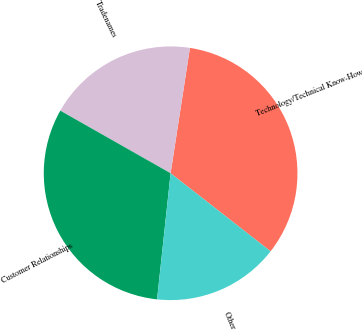Convert chart to OTSL. <chart><loc_0><loc_0><loc_500><loc_500><pie_chart><fcel>Technology/Technical Know-How<fcel>Tradenames<fcel>Customer Relationships<fcel>Other<nl><fcel>33.12%<fcel>19.22%<fcel>31.51%<fcel>16.15%<nl></chart> 